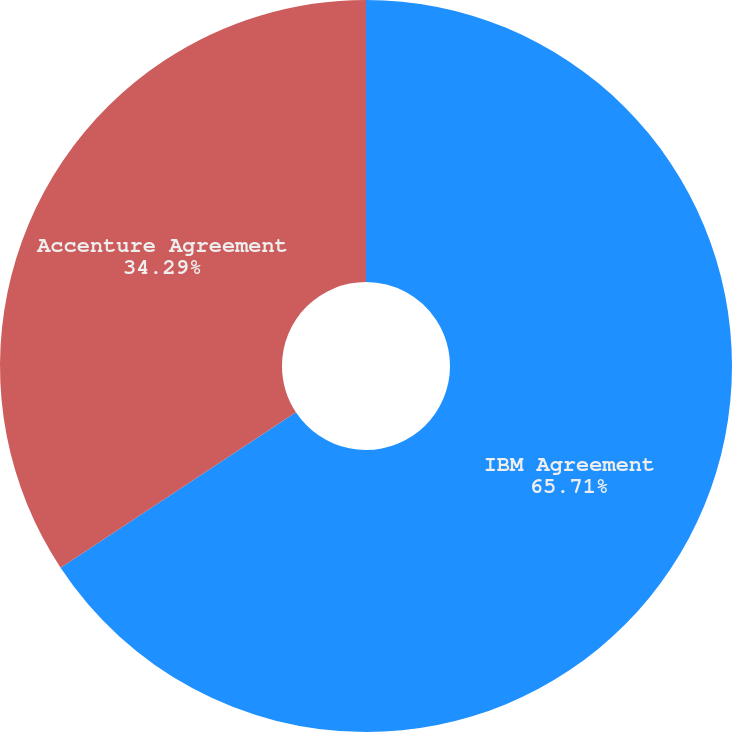Convert chart to OTSL. <chart><loc_0><loc_0><loc_500><loc_500><pie_chart><fcel>IBM Agreement<fcel>Accenture Agreement<nl><fcel>65.71%<fcel>34.29%<nl></chart> 